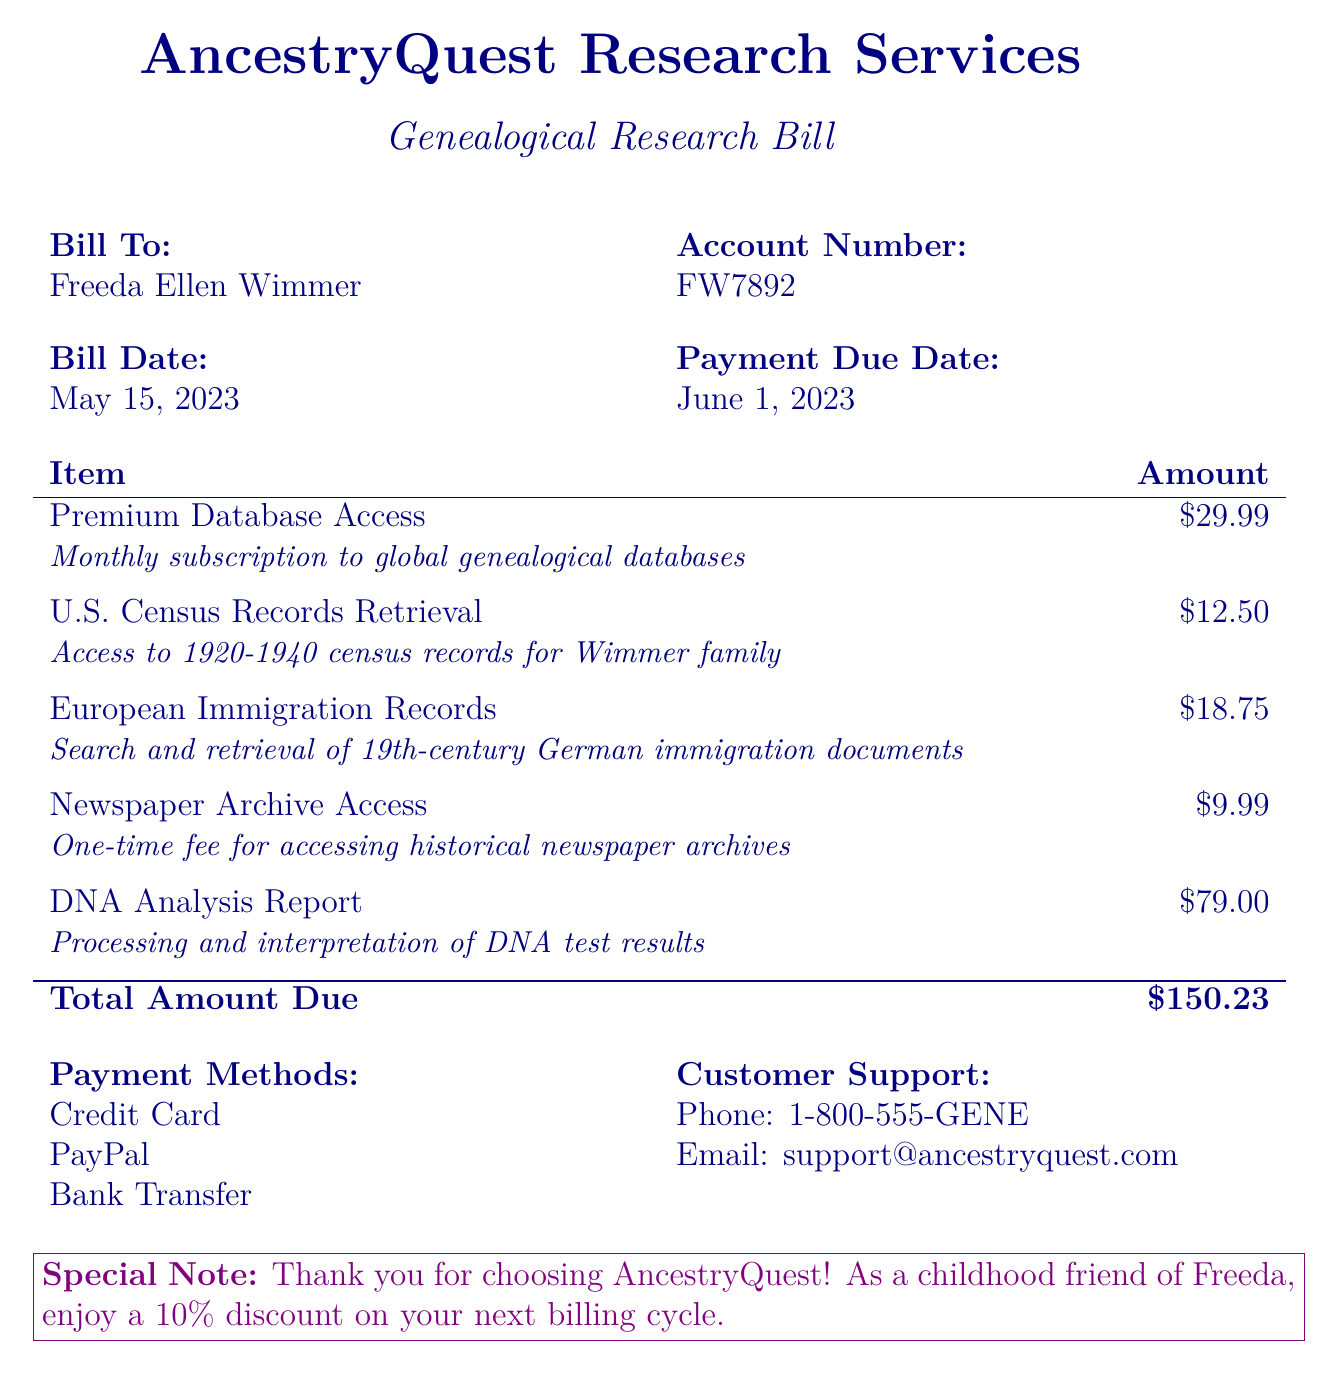What is the account number? The account number is provided in the billing details section of the document.
Answer: FW7892 What is the total amount due? The total amount due is listed at the bottom of the charges table in the document.
Answer: $150.23 What is the bill date? The bill date is clearly mentioned in the billing details section of the document.
Answer: May 15, 2023 How much is the premium database access? The cost of premium database access is indicated in the itemized charges.
Answer: $29.99 What document type does the bill cover? The document type is specified in the title of the bill.
Answer: Genealogical Research Bill How many types of document retrieval charges are listed? The document lists multiple itemized charges for database access and document retrieval.
Answer: Five What is the due date for payment? The due date for payment is mentioned in the billing details section.
Answer: June 1, 2023 What is the one-time fee for newspaper archive access? The fee for accessing historical newspaper archives is included in the itemized charges.
Answer: $9.99 What is the special note included in the document? The special note thanks the customer and offers a discount for future billing.
Answer: Thank you for choosing AncestryQuest! As a childhood friend of Freeda, enjoy a 10% discount on your next billing cycle 